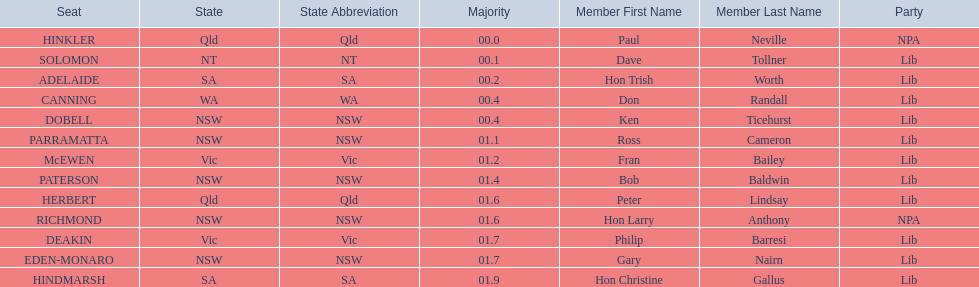Which seats are represented in the electoral system of australia? HINKLER, SOLOMON, ADELAIDE, CANNING, DOBELL, PARRAMATTA, McEWEN, PATERSON, HERBERT, RICHMOND, DEAKIN, EDEN-MONARO, HINDMARSH. What were their majority numbers of both hindmarsh and hinkler? HINKLER, HINDMARSH. Of those two seats, what is the difference in voting majority? 01.9. 